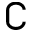<formula> <loc_0><loc_0><loc_500><loc_500>\complement</formula> 